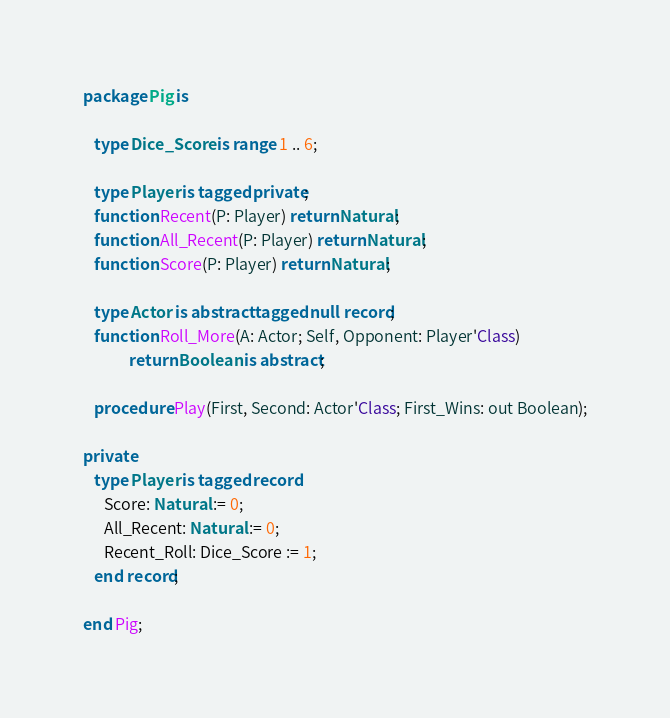Convert code to text. <code><loc_0><loc_0><loc_500><loc_500><_Ada_>package Pig is

   type Dice_Score is range 1 .. 6;

   type Player is tagged private;
   function Recent(P: Player) return Natural;
   function All_Recent(P: Player) return Natural;
   function Score(P: Player) return Natural;

   type Actor is abstract tagged null record;
   function Roll_More(A: Actor; Self, Opponent: Player'Class)
		     return Boolean is abstract;

   procedure Play(First, Second: Actor'Class; First_Wins: out Boolean);

private
   type Player is tagged record
      Score: Natural := 0;
      All_Recent: Natural := 0;
      Recent_Roll: Dice_Score := 1;
   end record;

end Pig;
</code> 